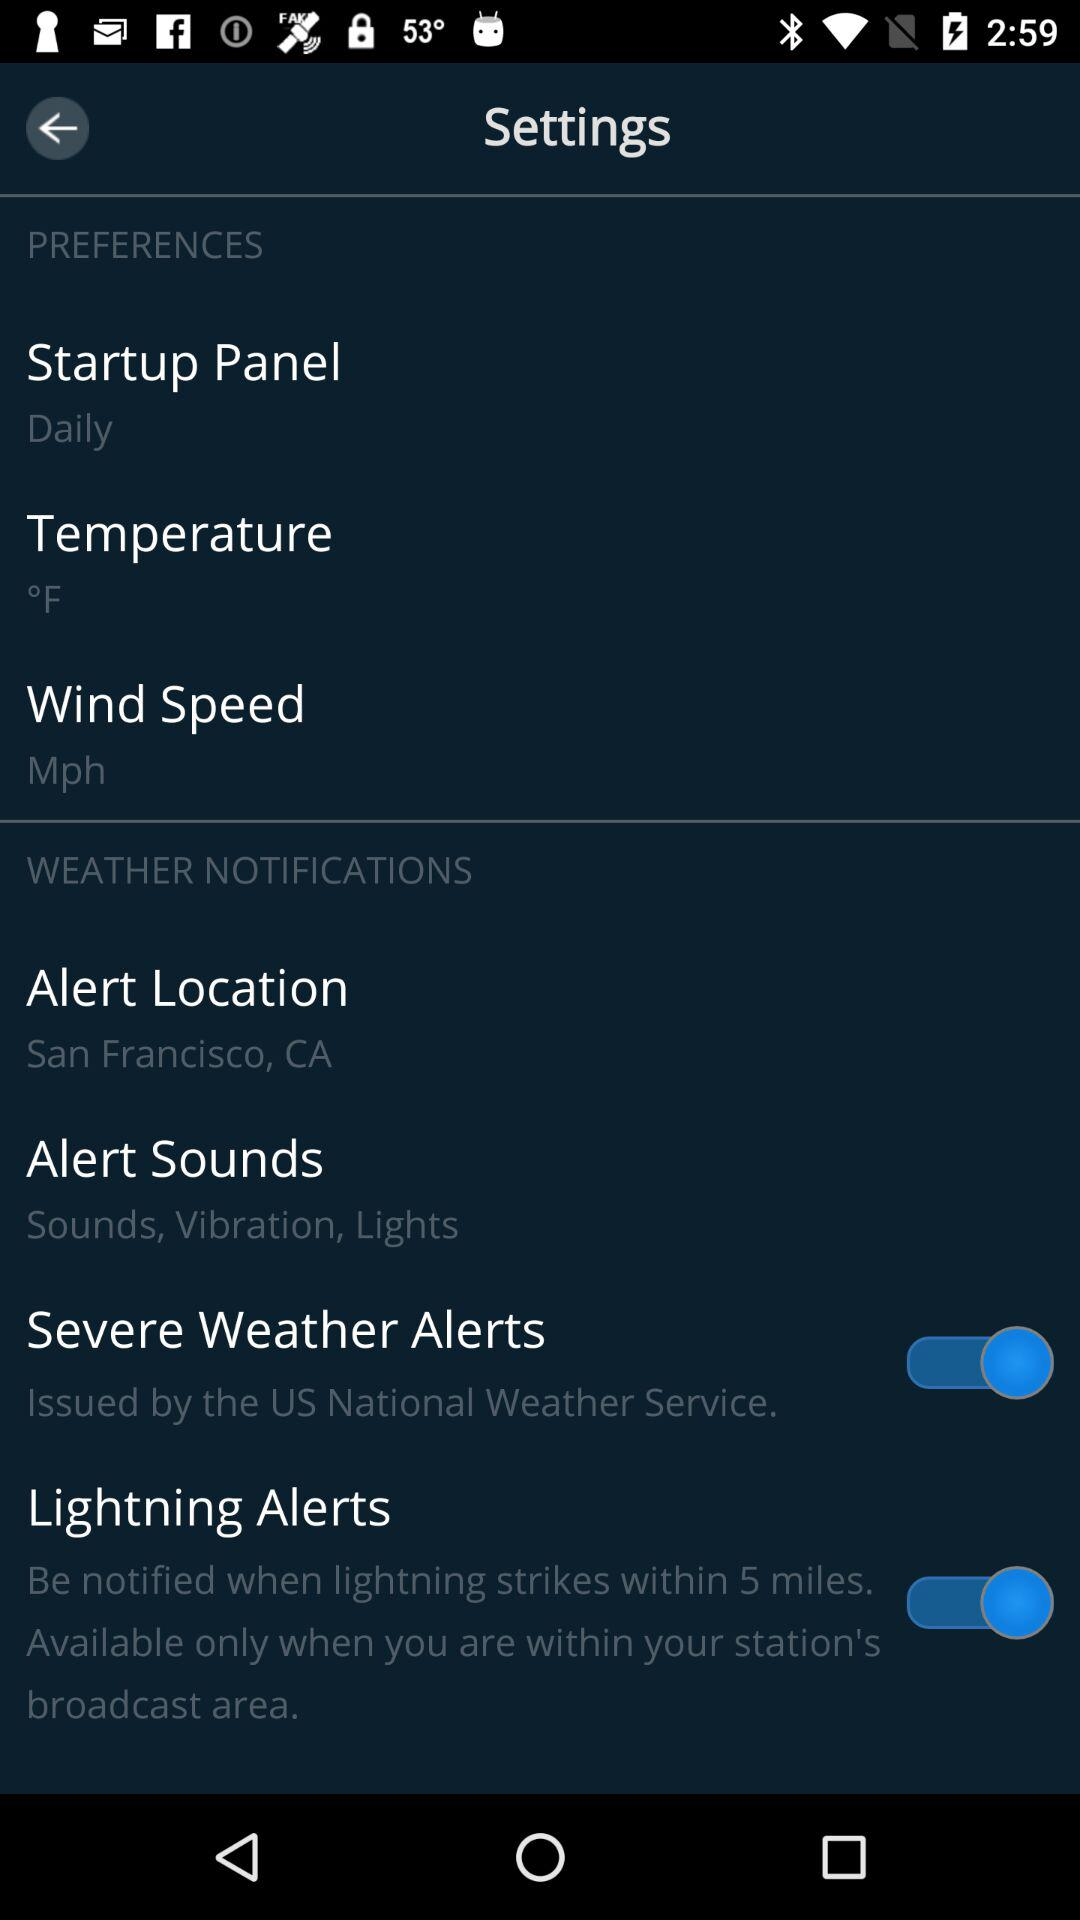How many items in the Weather Notifications section have a switch?
Answer the question using a single word or phrase. 2 